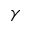Convert formula to latex. <formula><loc_0><loc_0><loc_500><loc_500>\gamma</formula> 